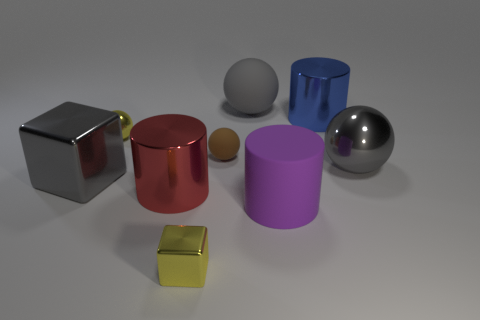What materials seem to be depicted in this image? The different objects in the image seem to be made of various materials. The shiny cube on the left might represent a metallic surface, the adjacent red and brown objects look like matte-finished ceramics or plastics, the cylinder and sphere on the right side have high-gloss surfaces suggesting metallic or glass materials, and the smaller objects look like they could be made of plastic or wood. 